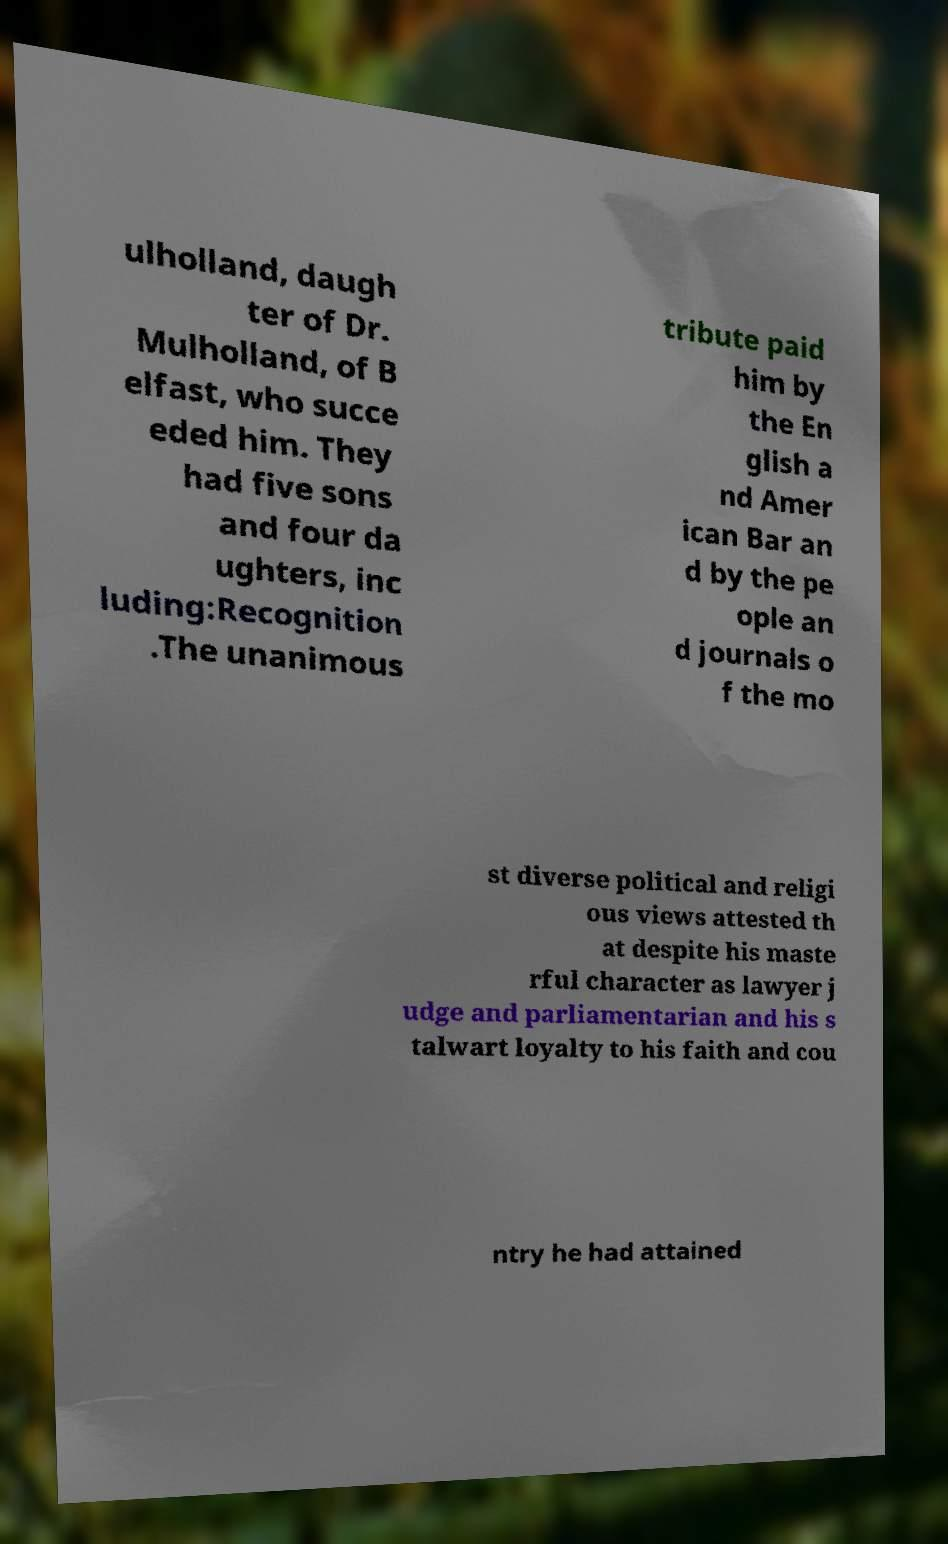Can you accurately transcribe the text from the provided image for me? ulholland, daugh ter of Dr. Mulholland, of B elfast, who succe eded him. They had five sons and four da ughters, inc luding:Recognition .The unanimous tribute paid him by the En glish a nd Amer ican Bar an d by the pe ople an d journals o f the mo st diverse political and religi ous views attested th at despite his maste rful character as lawyer j udge and parliamentarian and his s talwart loyalty to his faith and cou ntry he had attained 